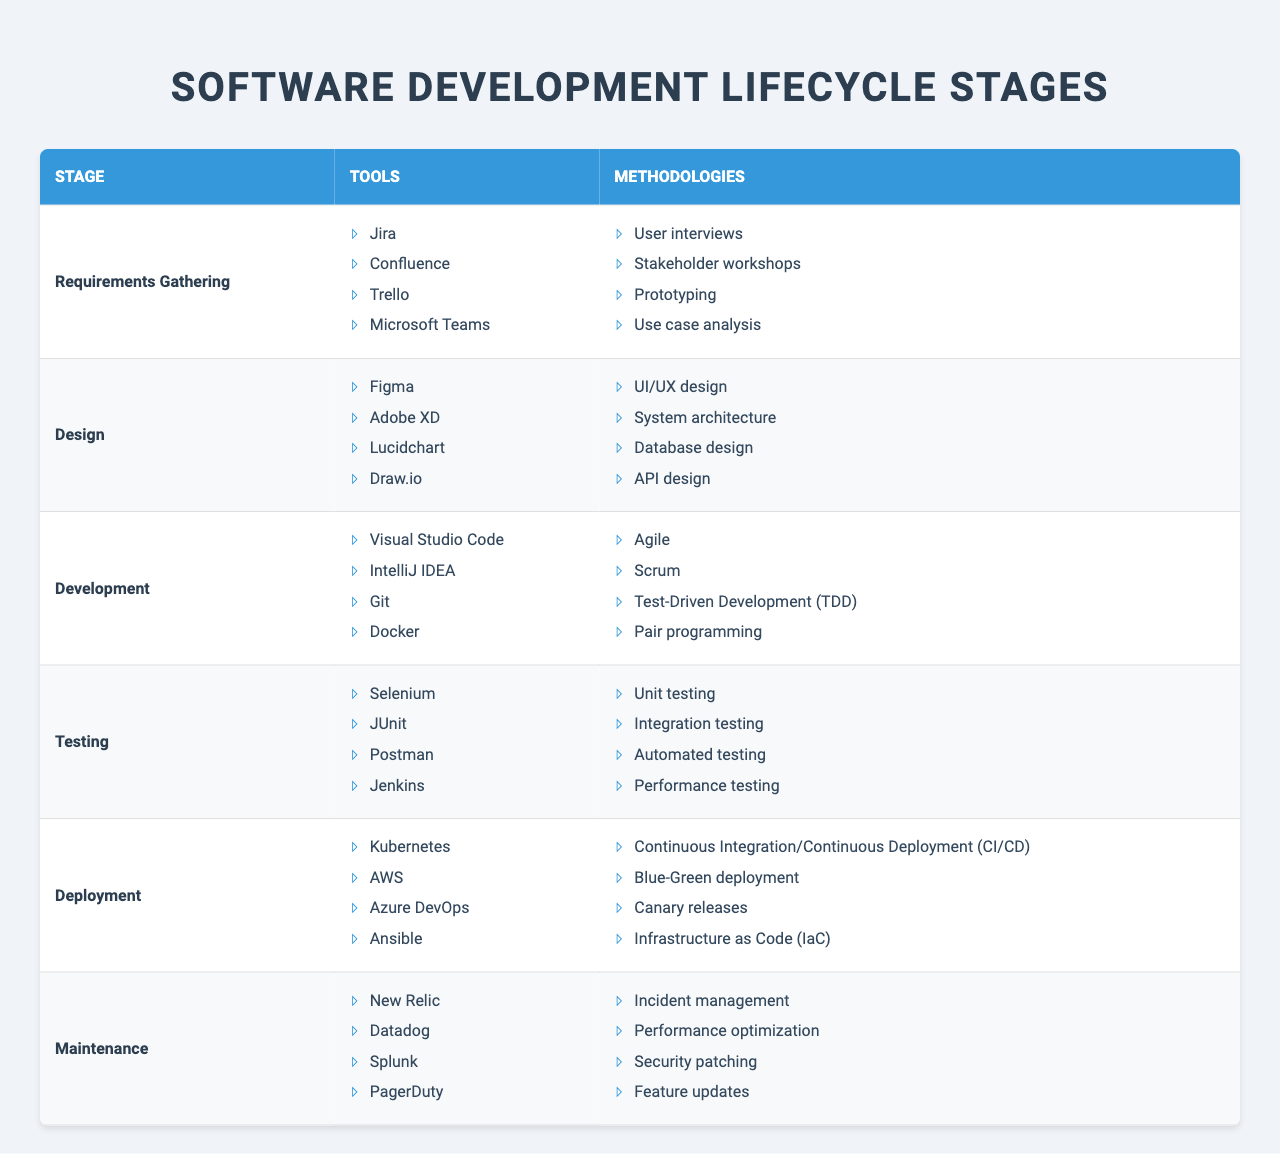What tools are used in the Development stage? The Development stage of the software development lifecycle lists four tools: Visual Studio Code, IntelliJ IDEA, Git, and Docker.
Answer: Visual Studio Code, IntelliJ IDEA, Git, Docker Which methodology is associated with the Testing stage? The Testing stage includes four methodologies: Unit testing, Integration testing, Automated testing, and Performance testing.
Answer: Unit testing, Integration testing, Automated testing, Performance testing Are there more tools in the Design stage than in the Requirements Gathering stage? Both the Design and Requirements Gathering stages have four tools each. Therefore, they do not differ in quantity.
Answer: No Which stage involves Continuous Integration/Continuous Deployment (CI/CD)? The Deployment stage is where Continuous Integration/Continuous Deployment (CI/CD) is mentioned as one of its methodologies.
Answer: Deployment stage What is the total number of unique methodologies listed in the table? By counting the methodologies from each stage: 4 (Requirements Gathering) + 4 (Design) + 4 (Development) + 4 (Testing) + 4 (Deployment) + 4 (Maintenance) equals a total of 24. However, there might be overlaps, but since they aren't specified, we assume no repeats for this.
Answer: 24 Is there any overlap between tools used in the Testing stage and the Deployment stage? The tools listed under the Testing stage (Selenium, JUnit, Postman, Jenkins) and the Deployment stage (Kubernetes, AWS, Azure DevOps, Ansible) are all distinct and do not overlap.
Answer: No Which stage has the most specialized tools, and what are they? The Maintenance stage has specialized tools focused on monitoring and incident management: New Relic, Datadog, Splunk, and PagerDuty. While all stages have specialized tools, Monitoring tools are particularly highlighted within Maintenance.
Answer: Maintenance stage How many methodologies are used for the Deployment stage in comparison to the Testing stage? Both Deployment and Testing stages have four methodologies each, thus they are equal in number.
Answer: Equal number Which tool would you use for UI/UX design? Figma and Adobe XD are both recognized tools specifically for UI/UX design in the Design stage.
Answer: Figma, Adobe XD In total, how many tools are listed across all stages? There are 4 tools per stage and 6 stages, so 4 x 6 equals a total of 24 tools listed across all stages.
Answer: 24 